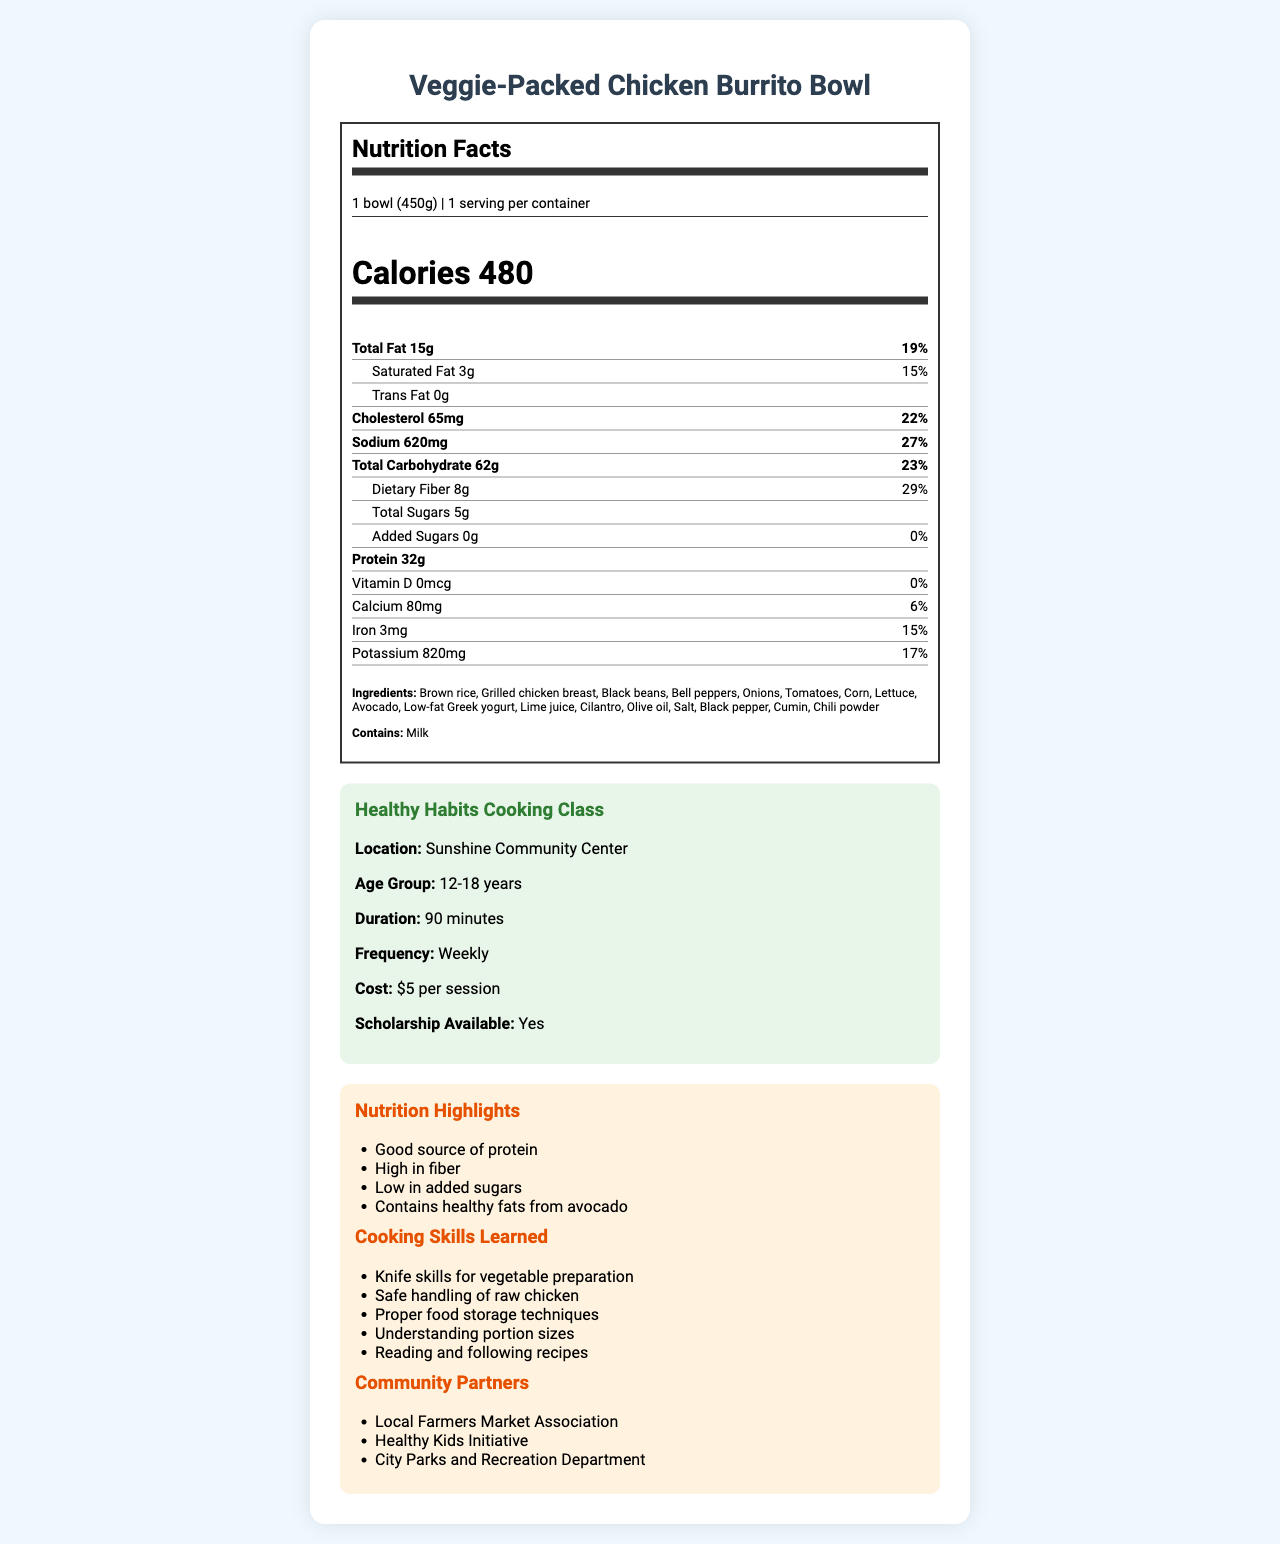What is the serving size of the Veggie-Packed Chicken Burrito Bowl? The serving size is clearly indicated as "1 bowl (450g)" in the Nutrition Facts section.
Answer: 1 bowl (450g) How many calories are in one serving of the Veggie-Packed Chicken Burrito Bowl? The document states "Calories 480" under the Nutrition Facts header.
Answer: 480 What is the total fat content in the Veggie-Packed Chicken Burrito Bowl? In the Nutrition Facts section, it lists "Total Fat 15g".
Answer: 15g How much dietary fiber does the Veggie-Packed Chicken Burrito Bowl contain? Under the Total Carbohydrate section, dietary fiber is listed as "8g".
Answer: 8g Does the Veggie-Packed Chicken Burrito Bowl contain any added sugars? The Nutrition Facts section shows "Added Sugars 0g", meaning there are no added sugars.
Answer: No Which of the following ingredients is NOT in the Veggie-Packed Chicken Burrito Bowl? A. Brown rice B. Black beans C. Chicken thighs D. Avocado Among the listed ingredients, "Grilled chicken breast" is included, not chicken thighs.
Answer: C. Chicken thighs What is the percentage of the daily value for sodium in the Veggie-Packed Chicken Burrito Bowl? A. 15% B. 22% C. 27% D. 33% Sodium in the Nutrition Facts section shows "27%" daily value.
Answer: C. 27% Does the meal contain allergens? The Ingredients section at the bottom states "Contains: Milk".
Answer: Yes How often is the Healthy Habits Cooking Class held? The frequency of the program is given as "Weekly" in the program info section.
Answer: Weekly Are scholarships available for the cooking class? The program information indicates "Scholarship Available: Yes".
Answer: Yes Summarize the main information provided about the meal and the cooking class it is associated with. The document provides detailed nutrition facts about the Veggie-Packed Chicken Burrito Bowl, outlines the ingredients and allergens, and describes the associated cooking class at the community center, including its benefits and partnerships.
Answer: The Veggie-Packed Chicken Burrito Bowl is a balanced meal option with 480 calories, 32g protein, 62g carbohydrates, and 15g fat. It includes healthy ingredients like brown rice, grilled chicken breast, and vegetables. The Healthy Habits Cooking Class at Sunshine Community Center is designed for ages 12-18, lasts 90 minutes, and costs $5 per session with scholarships available. The program covers significant cooking skills and partners with local organizations. What is the main source of healthy fats in the Veggie-Packed Chicken Burrito Bowl? The Nutrition Highlights specifically mention "Contains healthy fats from avocado".
Answer: Avocado What skills will participants learn in the cooking class? The Cooking Skills Learned section lists the specific skills taught in the class.
Answer: Knife skills for vegetable preparation, safe handling of raw chicken, proper food storage techniques, understanding portion sizes, reading and following recipes Is vitamin D present in the Veggie-Packed Chicken Burrito Bowl? The vitamin D value is listed as "0mcg" and "0%" daily value.
Answer: No Which community organization is NOT listed as a partner for the cooking class? Without knowing all possible community organizations, we can't confirm definitively which are not listed as partners. Only those given in the document can be known.
Answer: Cannot be determined 